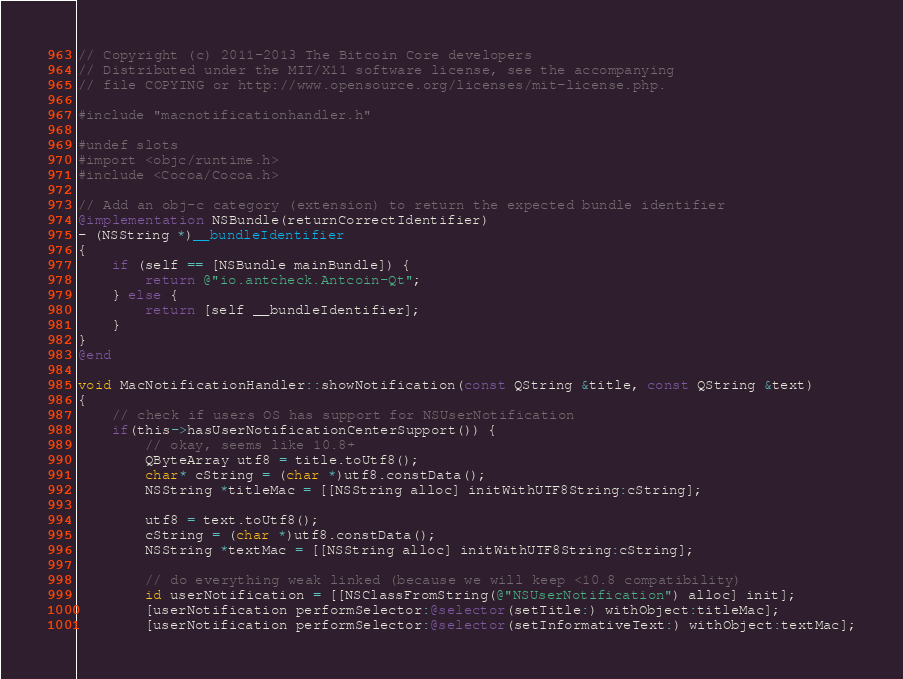Convert code to text. <code><loc_0><loc_0><loc_500><loc_500><_ObjectiveC_>// Copyright (c) 2011-2013 The Bitcoin Core developers
// Distributed under the MIT/X11 software license, see the accompanying
// file COPYING or http://www.opensource.org/licenses/mit-license.php.

#include "macnotificationhandler.h"

#undef slots
#import <objc/runtime.h>
#include <Cocoa/Cocoa.h>

// Add an obj-c category (extension) to return the expected bundle identifier
@implementation NSBundle(returnCorrectIdentifier)
- (NSString *)__bundleIdentifier
{
    if (self == [NSBundle mainBundle]) {
        return @"io.antcheck.Antcoin-Qt";
    } else {
        return [self __bundleIdentifier];
    }
}
@end

void MacNotificationHandler::showNotification(const QString &title, const QString &text)
{
    // check if users OS has support for NSUserNotification
    if(this->hasUserNotificationCenterSupport()) {
        // okay, seems like 10.8+
        QByteArray utf8 = title.toUtf8();
        char* cString = (char *)utf8.constData();
        NSString *titleMac = [[NSString alloc] initWithUTF8String:cString];

        utf8 = text.toUtf8();
        cString = (char *)utf8.constData();
        NSString *textMac = [[NSString alloc] initWithUTF8String:cString];

        // do everything weak linked (because we will keep <10.8 compatibility)
        id userNotification = [[NSClassFromString(@"NSUserNotification") alloc] init];
        [userNotification performSelector:@selector(setTitle:) withObject:titleMac];
        [userNotification performSelector:@selector(setInformativeText:) withObject:textMac];
</code> 